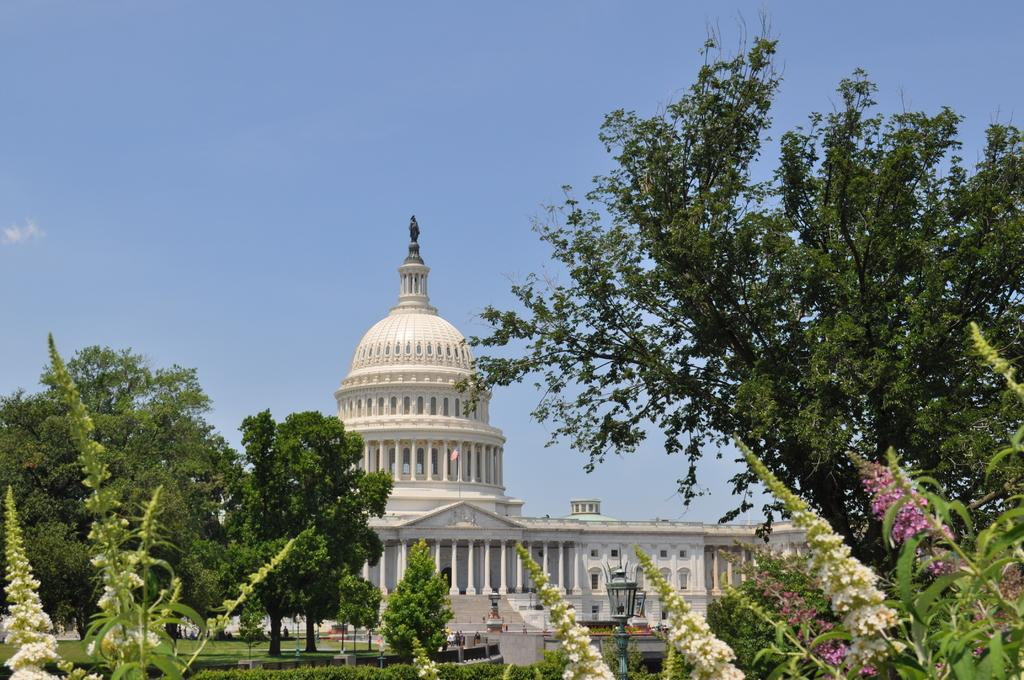What type of natural elements can be seen in the image? There are flowers and trees in the image. What type of artificial elements can be seen in the image? There are lights, poles, a flag, a building, pillars, windows, and a fountain in the image. What is visible in the background of the image? The sky is visible in the background of the image. Can you describe the unspecified objects in the image? Unfortunately, the facts provided do not specify the nature of these unspecified objects. How many roses are present in the image? The facts provided do not specify the type of flowers in the image, so we cannot determine if there are any roses present. Can you describe the jellyfish swimming in the fountain in the image? There are no jellyfish present in the image. 